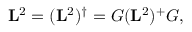Convert formula to latex. <formula><loc_0><loc_0><loc_500><loc_500>L ^ { 2 } = ( L ^ { 2 } ) ^ { \dagger } = G ( L ^ { 2 } ) ^ { + } G ,</formula> 